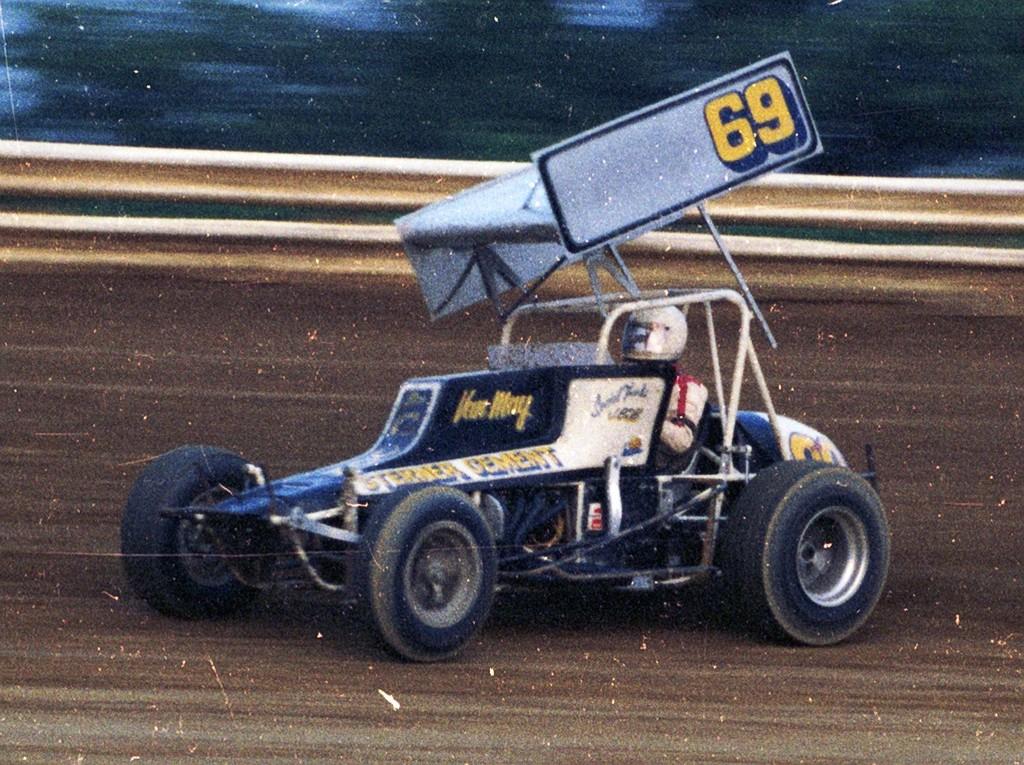What number is that race car?
Provide a succinct answer. 69. What number on the car?
Ensure brevity in your answer.  69. 